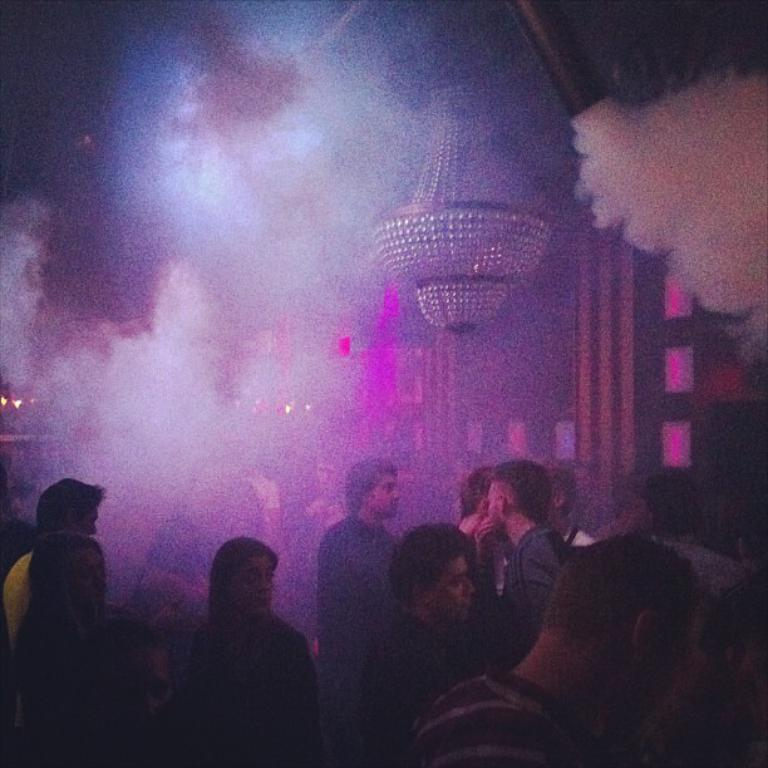How many people are present in the image? There are many people in the image. What can be seen in the background of the image? There is a wall in the background of the image. What is the source of the smoke visible at the top of the image? The source of the smoke is not visible in the image, but it is present at the top. What type of lighting fixture is in the image? There is a chandelier in the image. What type of chalk is being used by the people in the image? There is no chalk present in the image; it does not mention any chalk-related activity. 